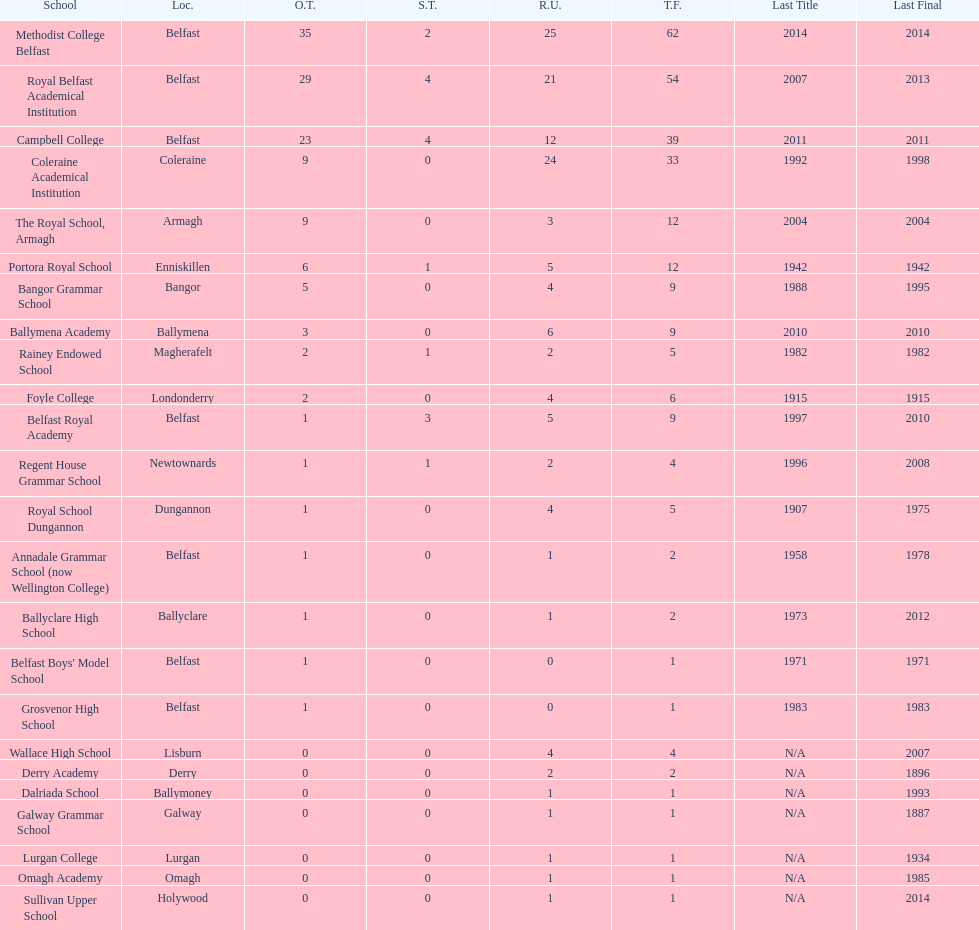Which schools have the largest number of shared titles? Royal Belfast Academical Institution, Campbell College. 